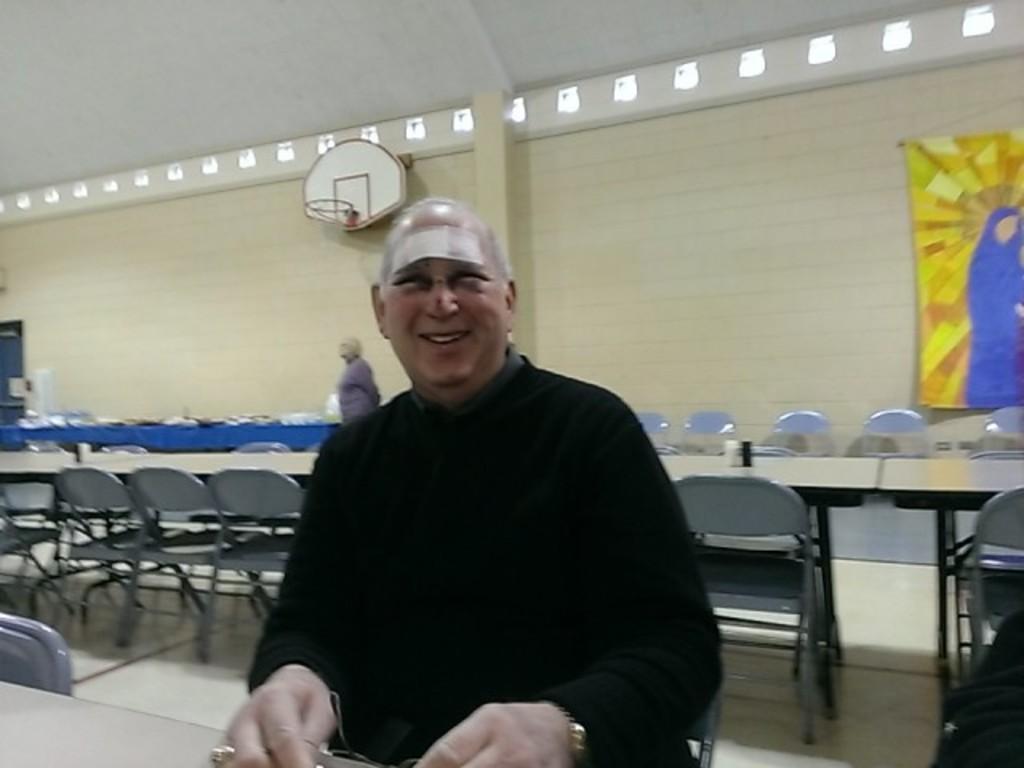Could you give a brief overview of what you see in this image? There is a man with black jacket is sitting on a chair in front of the table. There are many chairs to the back of him and many tables. There is a lady standing behind him. There is a wall. And to the top right corner there is a flag. And to the left side corner there is a door. And to the top side there is a basketball basket. 